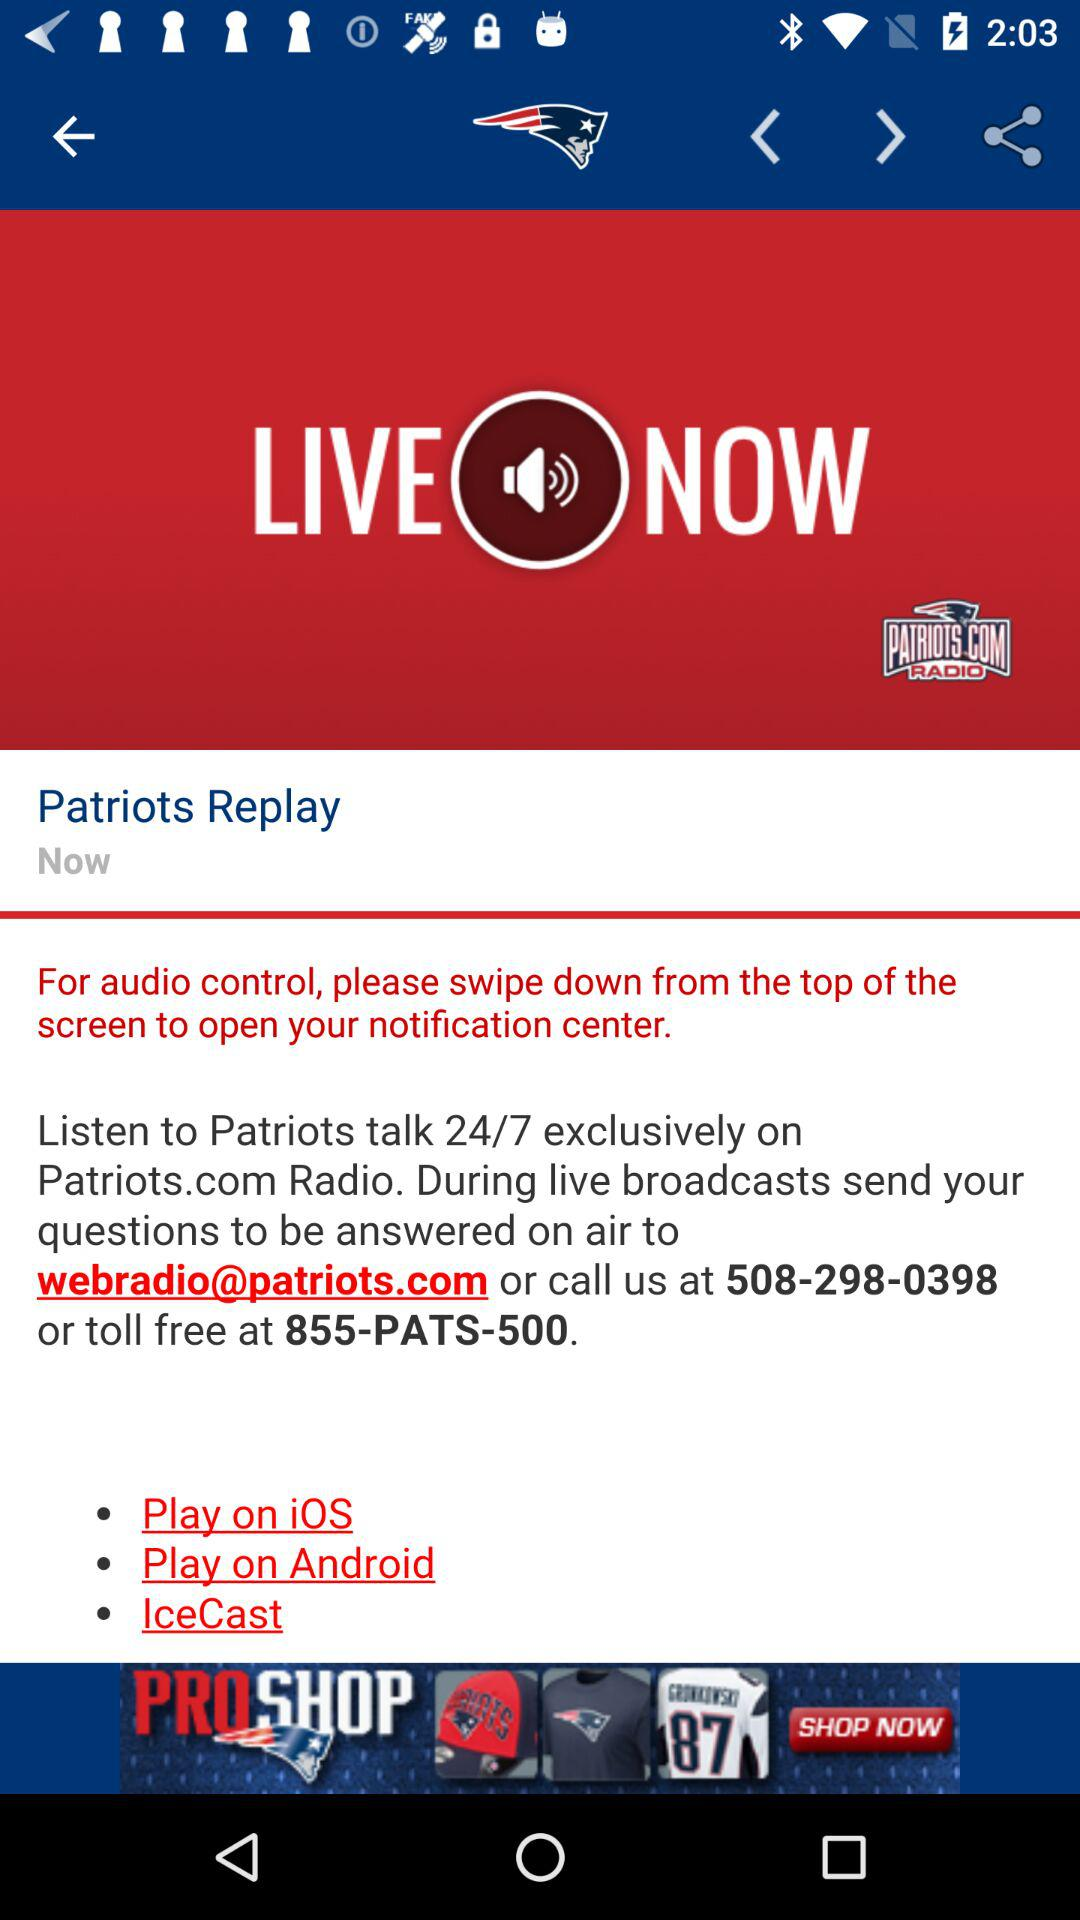What is the toll-free number? The toll-free number is 855-PATS-500. 